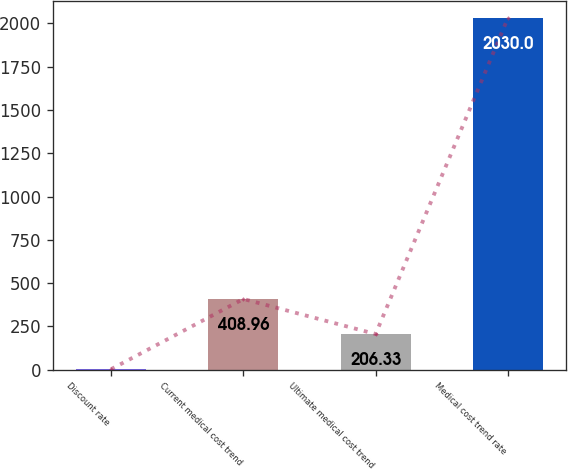<chart> <loc_0><loc_0><loc_500><loc_500><bar_chart><fcel>Discount rate<fcel>Current medical cost trend<fcel>Ultimate medical cost trend<fcel>Medical cost trend rate<nl><fcel>3.7<fcel>408.96<fcel>206.33<fcel>2030<nl></chart> 